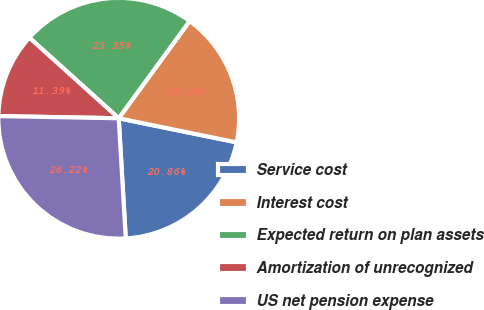<chart> <loc_0><loc_0><loc_500><loc_500><pie_chart><fcel>Service cost<fcel>Interest cost<fcel>Expected return on plan assets<fcel>Amortization of unrecognized<fcel>US net pension expense<nl><fcel>20.86%<fcel>18.18%<fcel>23.35%<fcel>11.39%<fcel>26.22%<nl></chart> 